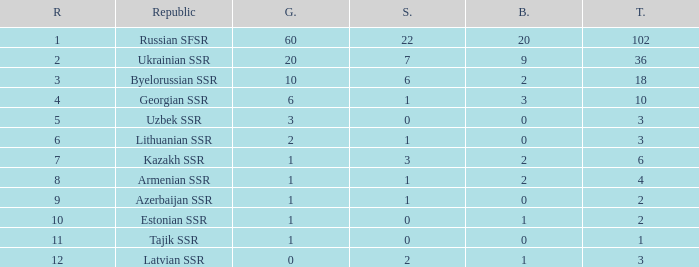What is the highest number of bronzes for teams ranked number 7 with more than 0 silver? 2.0. 